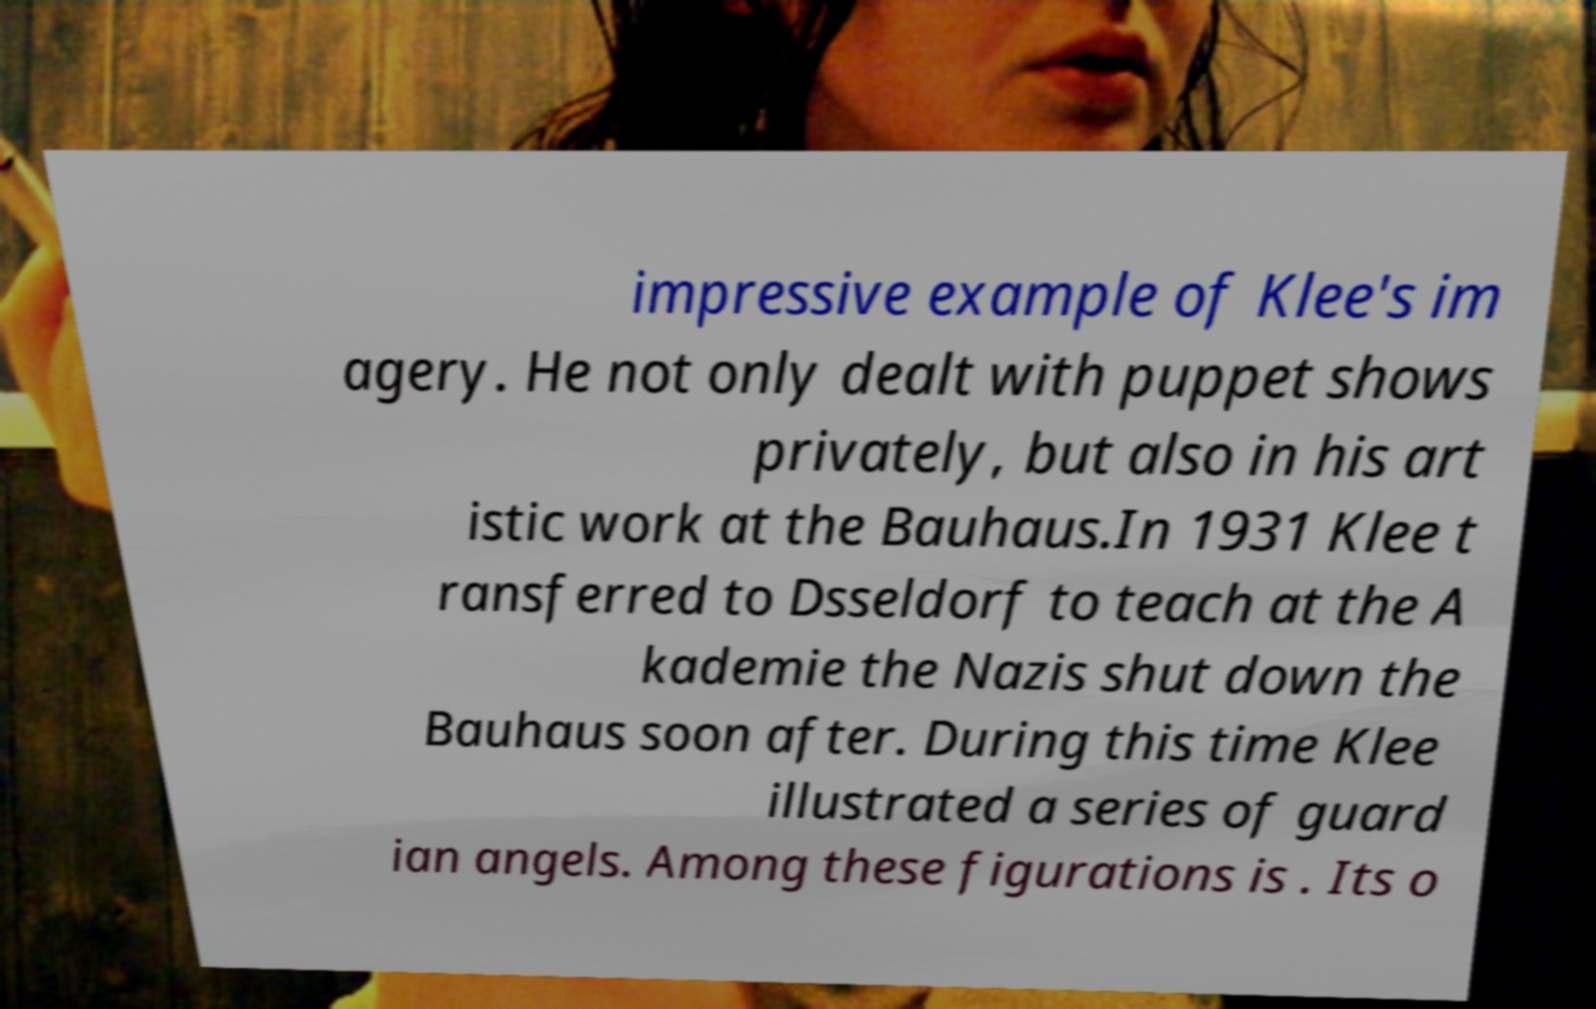Can you accurately transcribe the text from the provided image for me? impressive example of Klee's im agery. He not only dealt with puppet shows privately, but also in his art istic work at the Bauhaus.In 1931 Klee t ransferred to Dsseldorf to teach at the A kademie the Nazis shut down the Bauhaus soon after. During this time Klee illustrated a series of guard ian angels. Among these figurations is . Its o 